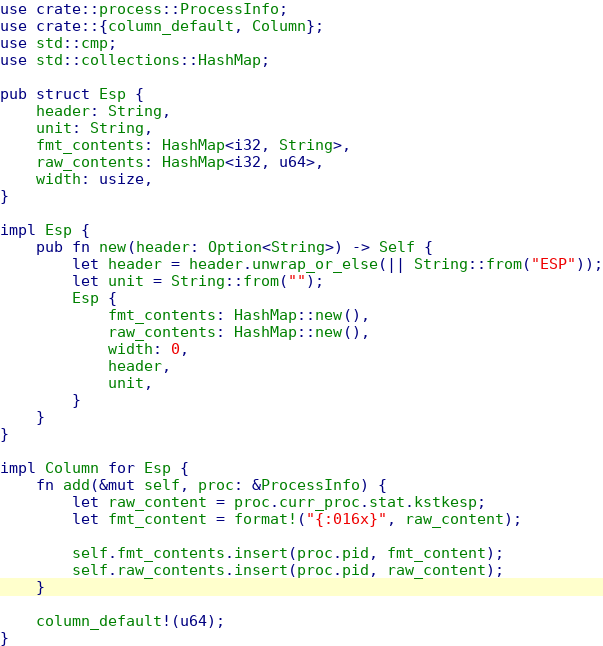<code> <loc_0><loc_0><loc_500><loc_500><_Rust_>use crate::process::ProcessInfo;
use crate::{column_default, Column};
use std::cmp;
use std::collections::HashMap;

pub struct Esp {
    header: String,
    unit: String,
    fmt_contents: HashMap<i32, String>,
    raw_contents: HashMap<i32, u64>,
    width: usize,
}

impl Esp {
    pub fn new(header: Option<String>) -> Self {
        let header = header.unwrap_or_else(|| String::from("ESP"));
        let unit = String::from("");
        Esp {
            fmt_contents: HashMap::new(),
            raw_contents: HashMap::new(),
            width: 0,
            header,
            unit,
        }
    }
}

impl Column for Esp {
    fn add(&mut self, proc: &ProcessInfo) {
        let raw_content = proc.curr_proc.stat.kstkesp;
        let fmt_content = format!("{:016x}", raw_content);

        self.fmt_contents.insert(proc.pid, fmt_content);
        self.raw_contents.insert(proc.pid, raw_content);
    }

    column_default!(u64);
}
</code> 